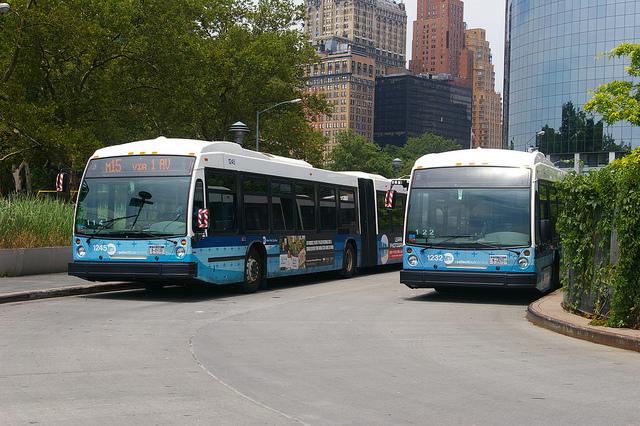Are the lines on the pavement?
Write a very short answer. No. How many busses are in the picture?
Write a very short answer. 2. What color stripes are on the side mirrors on the bus?
Give a very brief answer. Red and white. How many buses are there?
Concise answer only. 2. 